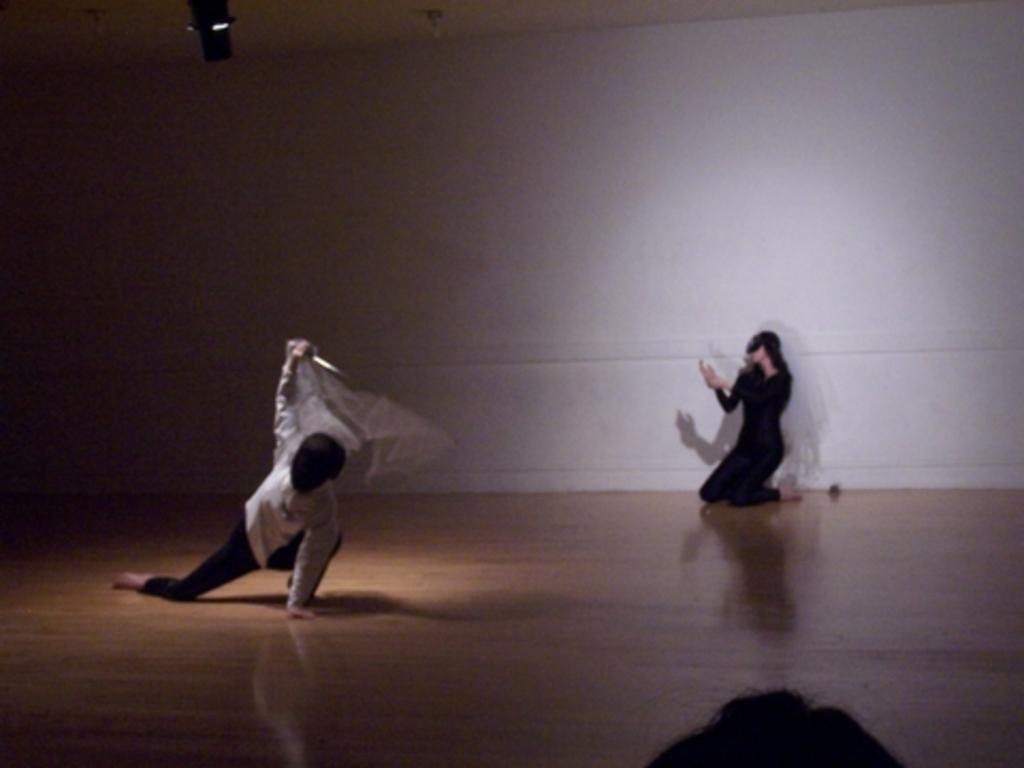Could you give a brief overview of what you see in this image? On the left side a man is performing the different action. on the right side a woman wore black color dress and performing the action. 